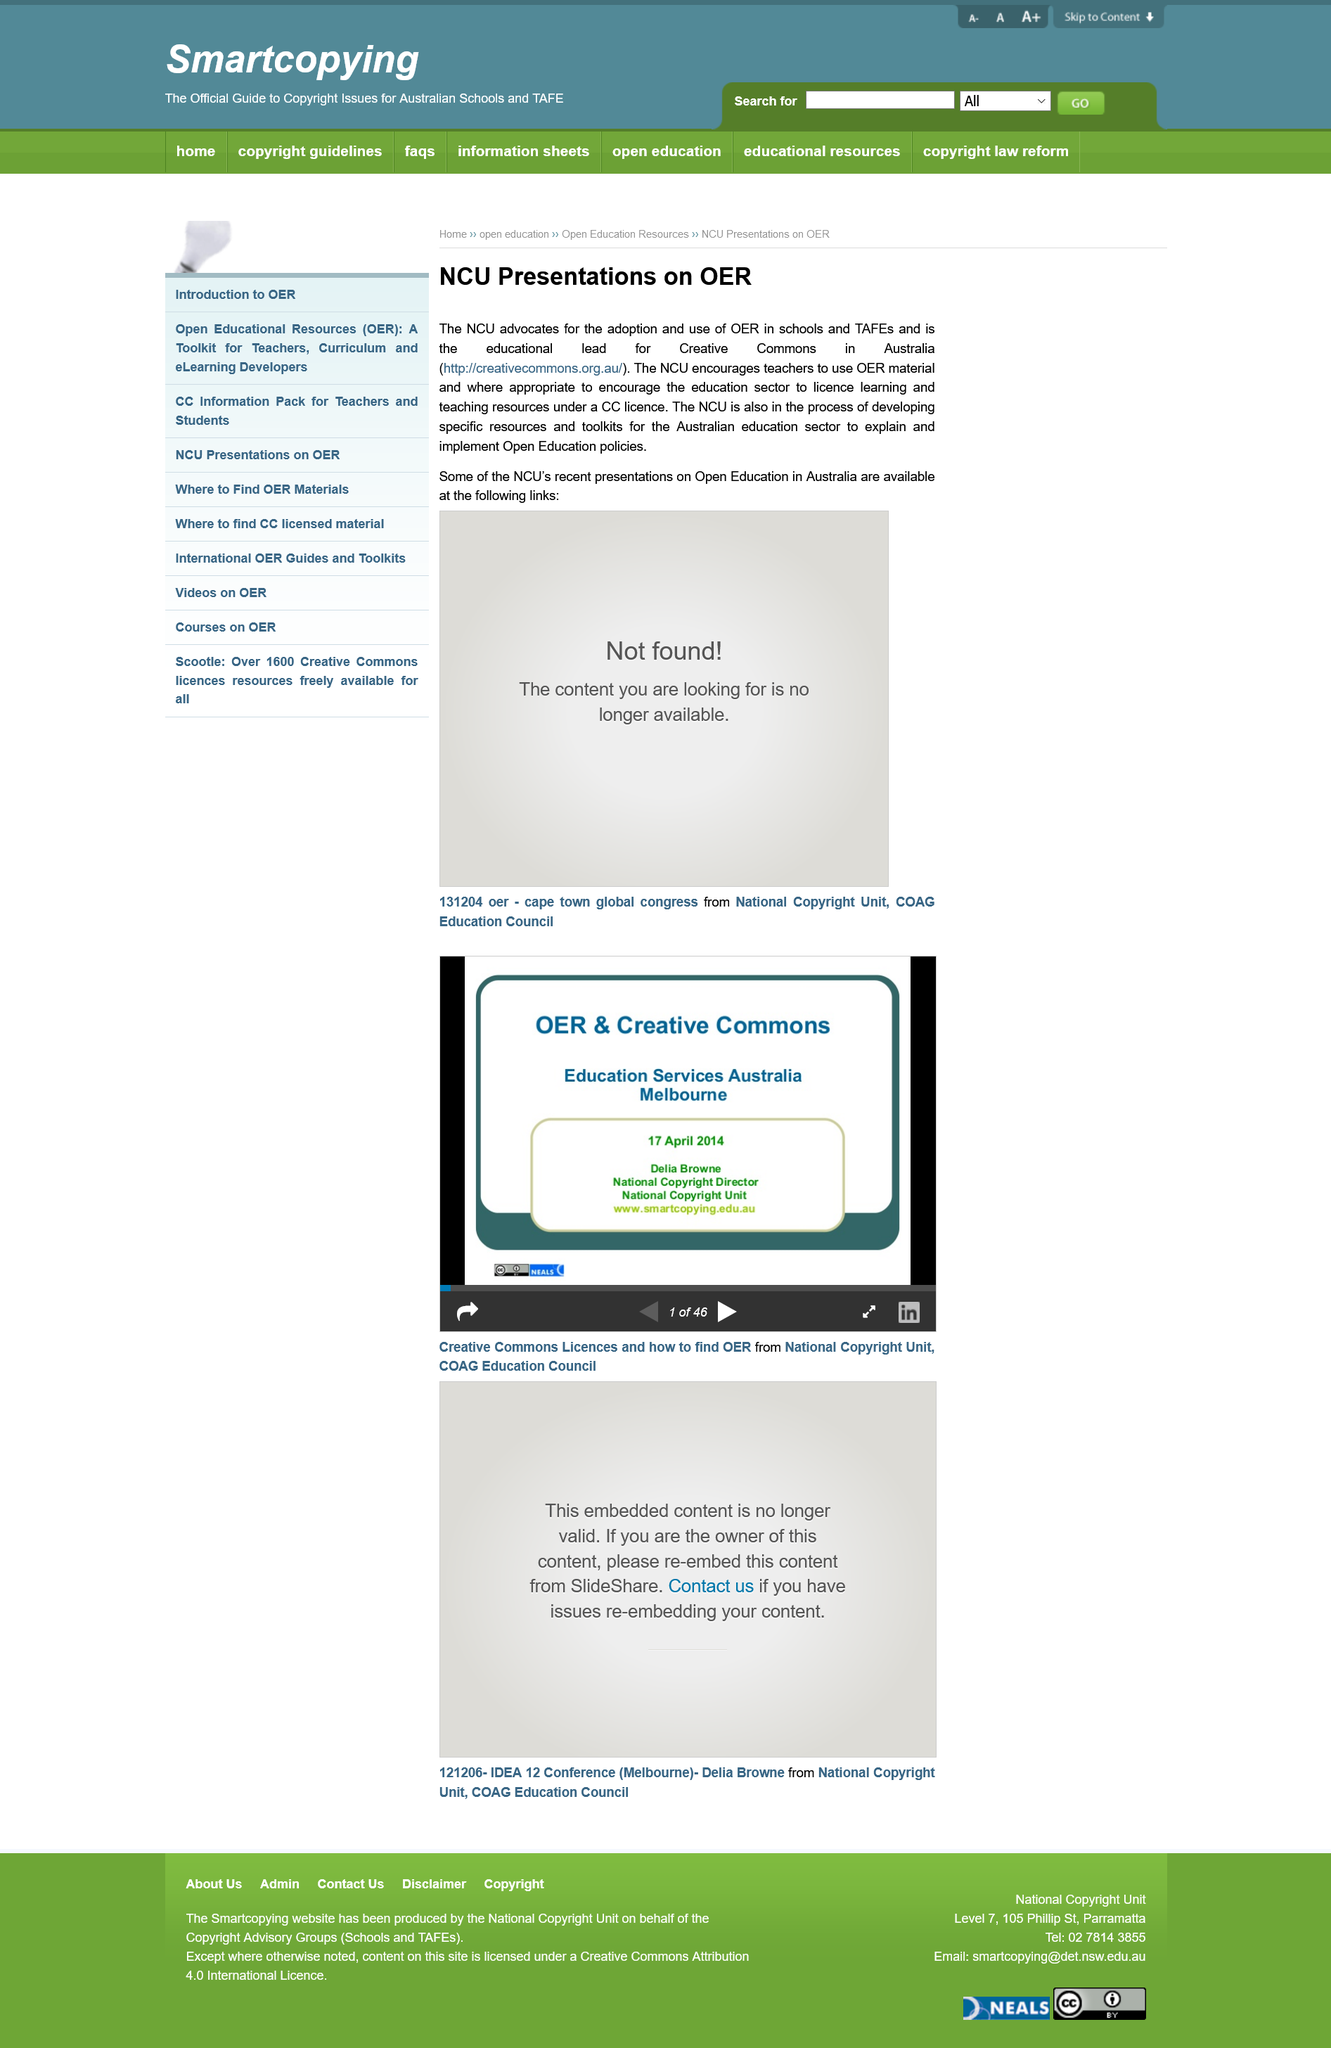Indicate a few pertinent items in this graphic. The article is discussing the country of Australia. The three-letter abbreviation NCU is the first word in the title of the article and the second word in the article itself. The abbreviation for the type of license being discussed in the article is "CC. 